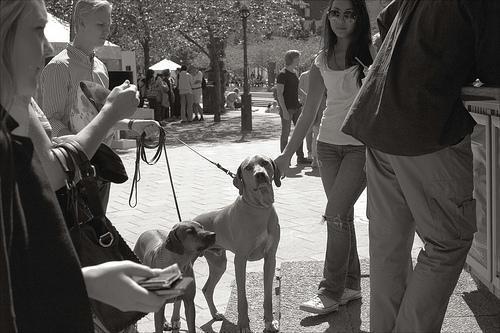How many dogs are there?
Give a very brief answer. 2. How many umbrellas are in the image?
Give a very brief answer. 1. 